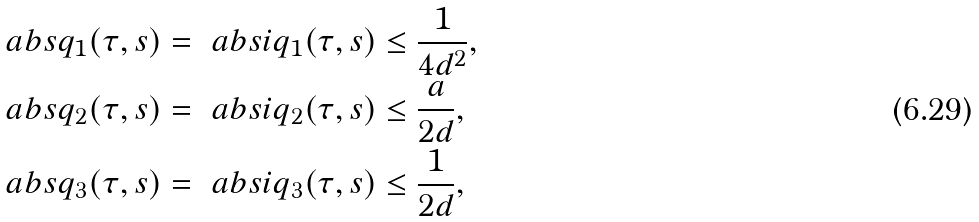Convert formula to latex. <formula><loc_0><loc_0><loc_500><loc_500>\ a b s { q _ { 1 } ( \tau , s ) } & = \ a b s { i q _ { 1 } ( \tau , s ) } \leq \frac { 1 } { 4 d ^ { 2 } } , \\ \ a b s { q _ { 2 } ( \tau , s ) } & = \ a b s { i q _ { 2 } ( \tau , s ) } \leq \frac { a } { 2 d } , \\ \ a b s { q _ { 3 } ( \tau , s ) } & = \ a b s { i q _ { 3 } ( \tau , s ) } \leq \frac { 1 } { 2 d } ,</formula> 